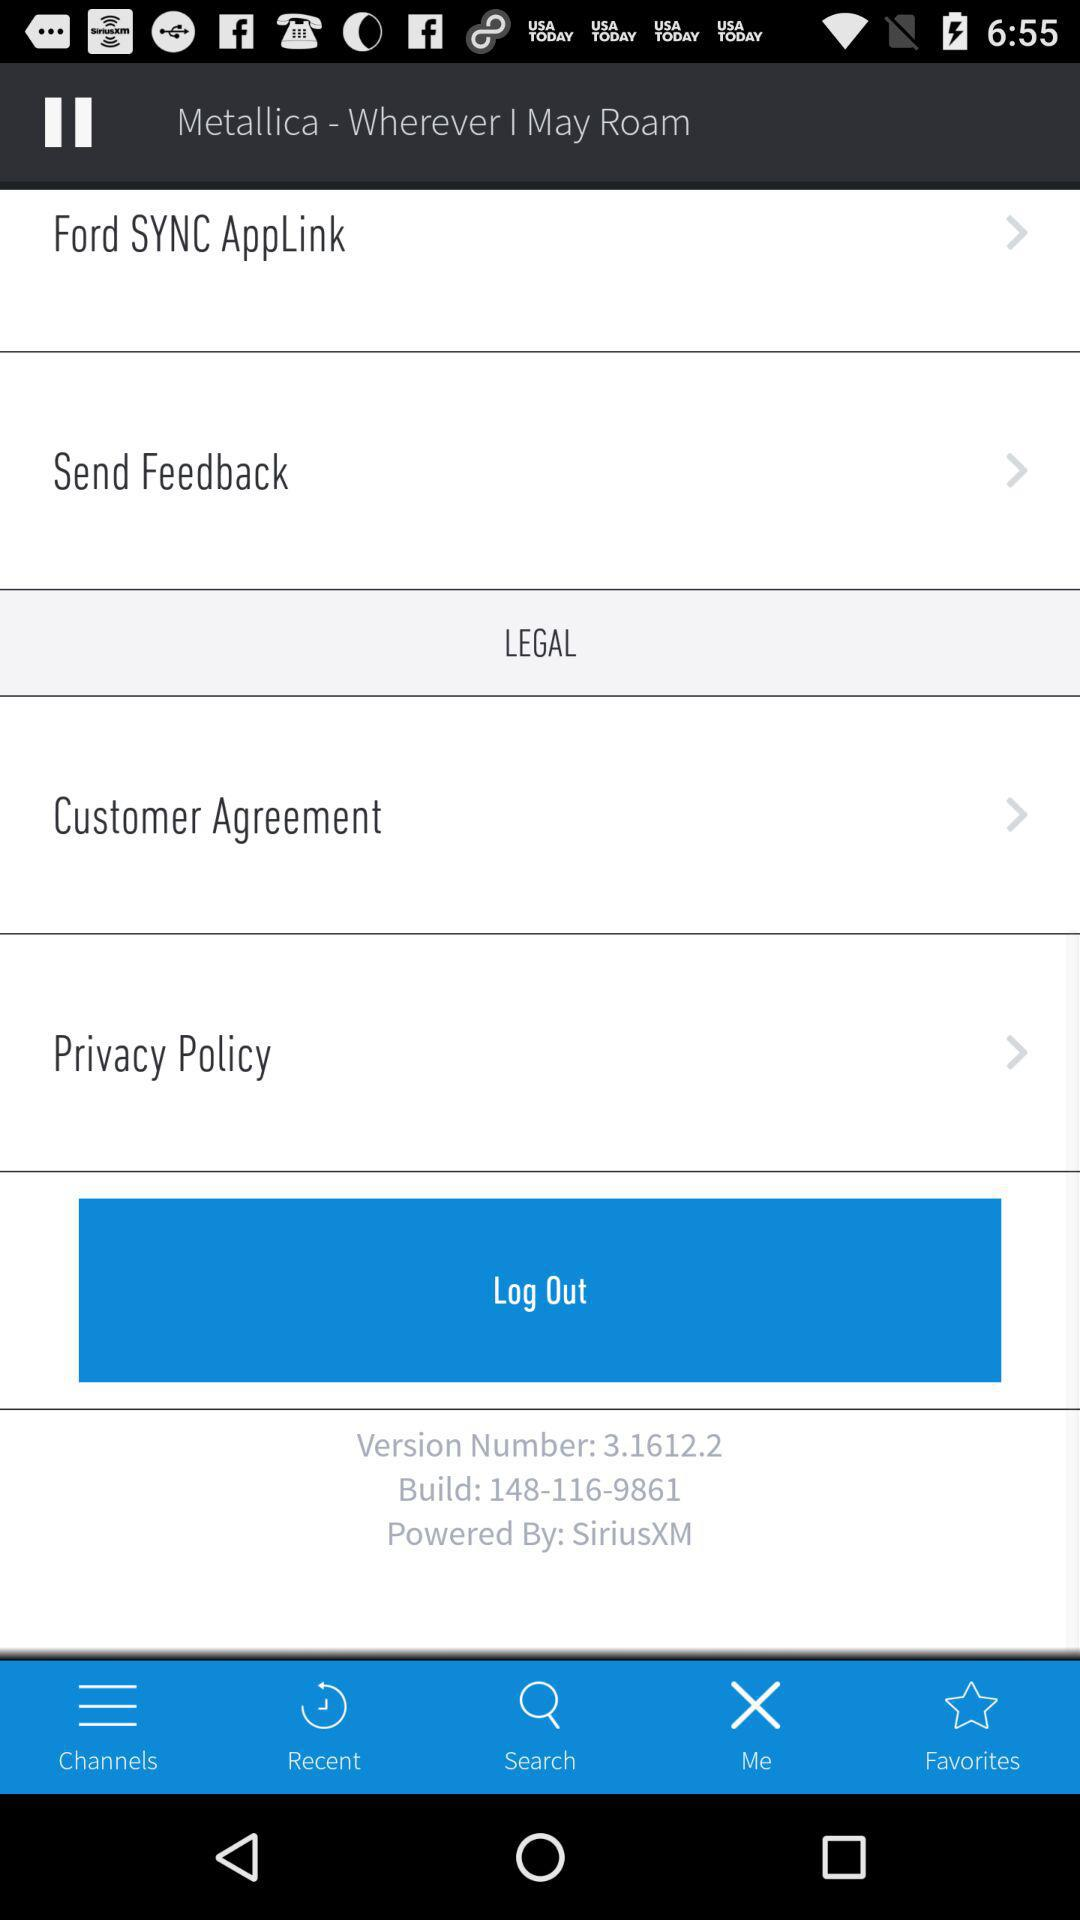What is the username? The username is "appcrawler5@gmail.com". 